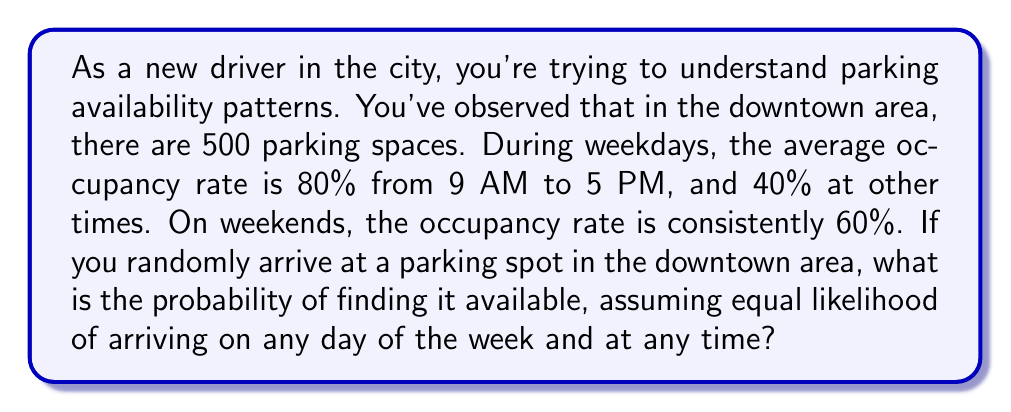Provide a solution to this math problem. Let's approach this step-by-step:

1) First, we need to calculate the probability of arriving during different time periods:
   - Weekday, 9 AM to 5 PM: (5/7) * (8/24) = 40/168
   - Weekday, other times: (5/7) * (16/24) = 80/168
   - Weekend: 2/7 = 48/168

2) Now, let's calculate the availability rate for each period:
   - Weekday, 9 AM to 5 PM: 1 - 0.80 = 0.20 (20% available)
   - Weekday, other times: 1 - 0.40 = 0.60 (60% available)
   - Weekend: 1 - 0.60 = 0.40 (40% available)

3) We can now calculate the probability of finding an available spot in each period:
   - Weekday, 9 AM to 5 PM: (40/168) * 0.20 = 8/168
   - Weekday, other times: (80/168) * 0.60 = 48/168
   - Weekend: (48/168) * 0.40 = 19.2/168

4) The total probability is the sum of these:

   $$ P(\text{available}) = \frac{8}{168} + \frac{48}{168} + \frac{19.2}{168} = \frac{75.2}{168} $$

5) Simplifying this fraction:

   $$ P(\text{available}) = \frac{75.2}{168} = \frac{376}{840} = \frac{47}{105} \approx 0.4476 $$
Answer: The probability of finding an available parking spot is $\frac{47}{105}$ or approximately 0.4476 (44.76%). 